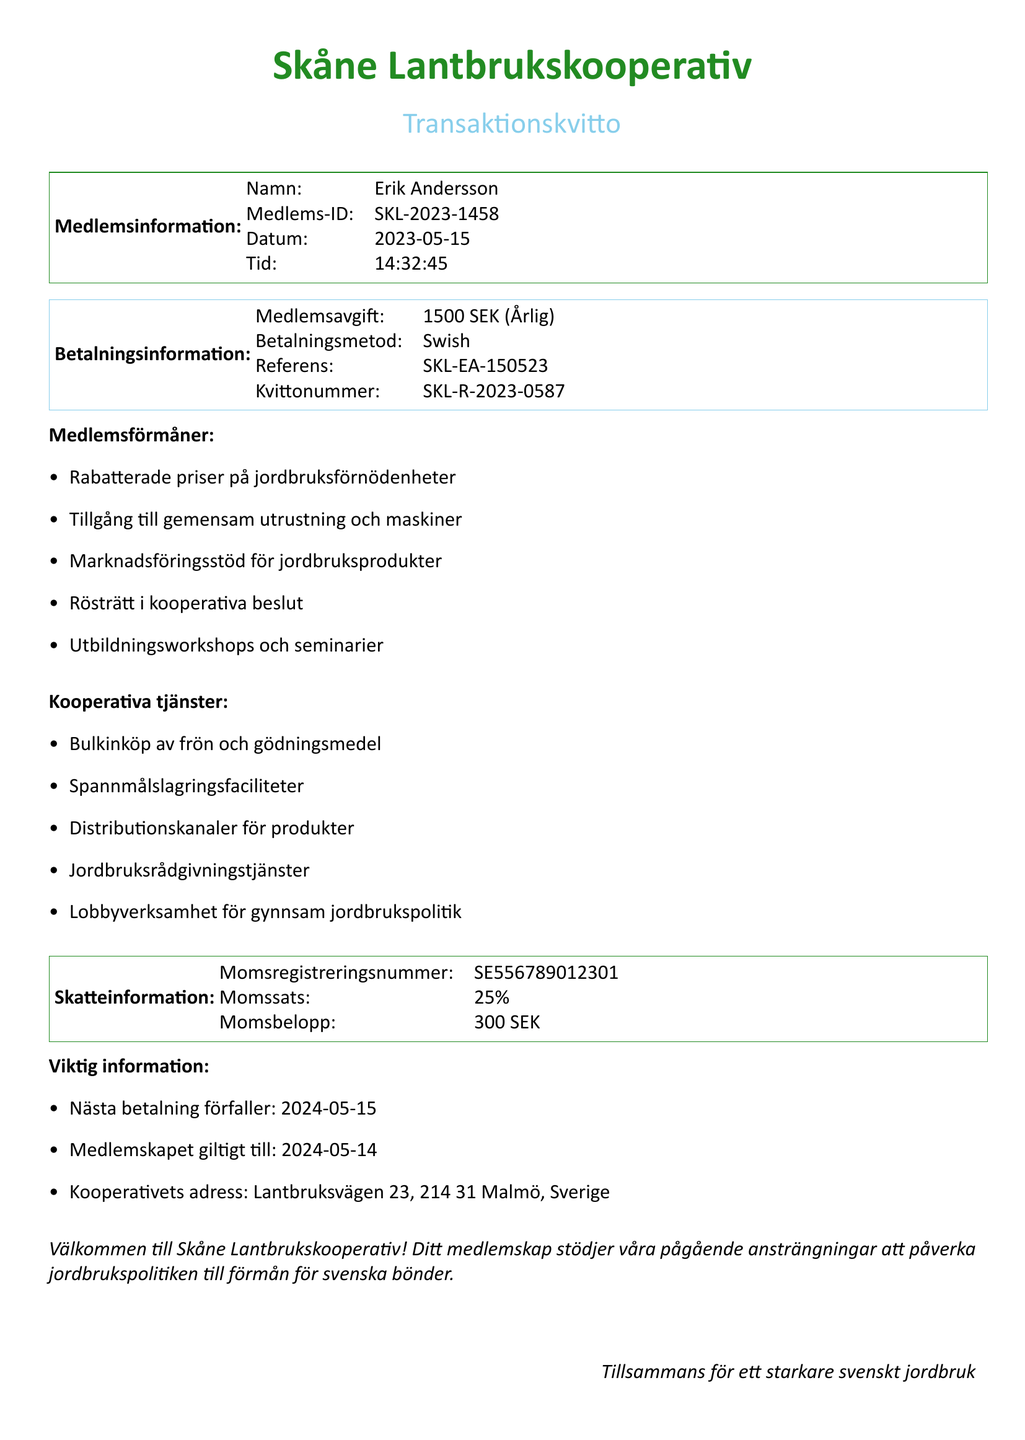What is the name of the cooperative? The cooperative's name is mentioned at the top of the document as "Skåne Lantbrukskooperativ."
Answer: Skåne Lantbrukskooperativ Who is the member? The member's name appears in the member information section of the document as "Erik Andersson."
Answer: Erik Andersson What is the membership fee amount? The document specifies that the membership fee is "1500 SEK (Årlig)."
Answer: 1500 SEK What date does the membership expire? The expiration date is stated in the important information section as "2024-05-14."
Answer: 2024-05-14 What is the payment method used? The payment method is clearly listed in the payment information section as "Swish."
Answer: Swish What are the benefits of membership? The document lists several member benefits, highlighting key perks for members.
Answer: Discounted prices on agricultural supplies What is the VAT amount included in the transaction? The document provides the VAT amount as "300 SEK" under the tax information section.
Answer: 300 SEK What type of document is this? The document title indicates it is a "Transaktionskvitto," which translates to transaction receipt.
Answer: Transaktionskvitto Who is the chairperson of the cooperative? The document mentions "Lena Svensson" as the chairperson in the board of directors section.
Answer: Lena Svensson 